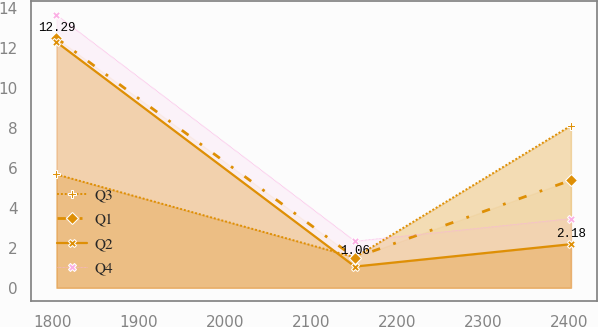Convert chart. <chart><loc_0><loc_0><loc_500><loc_500><line_chart><ecel><fcel>Q3<fcel>Q1<fcel>Q2<fcel>Q4<nl><fcel>1804.72<fcel>5.67<fcel>12.49<fcel>12.29<fcel>13.65<nl><fcel>2151.24<fcel>1.52<fcel>1.51<fcel>1.06<fcel>2.33<nl><fcel>2402.07<fcel>8.11<fcel>5.38<fcel>2.18<fcel>3.46<nl></chart> 